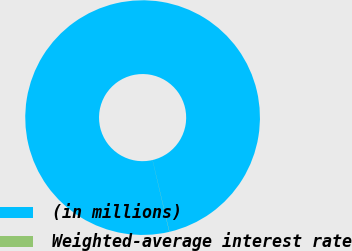Convert chart. <chart><loc_0><loc_0><loc_500><loc_500><pie_chart><fcel>(in millions)<fcel>Weighted-average interest rate<nl><fcel>99.98%<fcel>0.02%<nl></chart> 